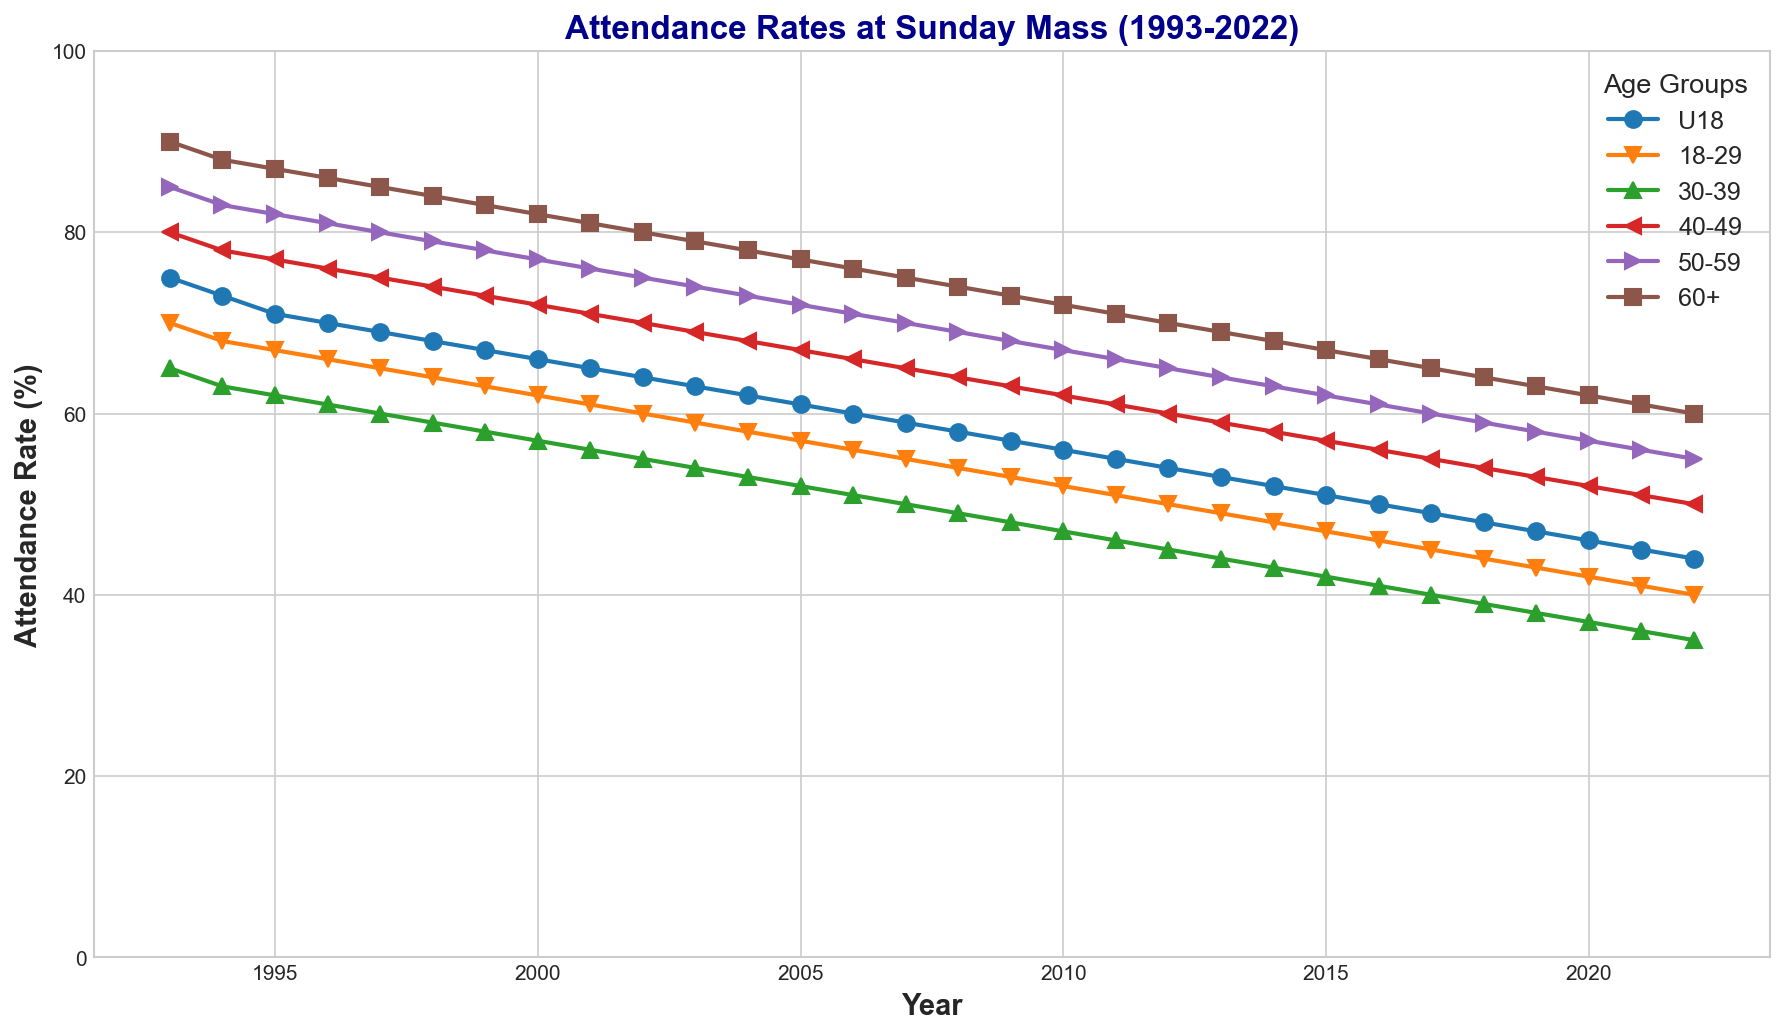what is the overall trend in attendance rates for the age group 18-29 from 1993 to 2022? To determine the overall trend, we look at the start (1993) and end values (2022) of the attendance rates for the 18-29 age group. In 1993, the rate was 70%, and in 2022, it was 40%. The trend is a decline in attendance over the period.
Answer: Declining which age group had the highest attendance rate in 1993 and 2022? In 1993, we observe the highest attendance rate by comparing the values for each age group. The 60+ age group had the highest rate at 90%. Repeating the process for 2022, the 60+ age group again had the highest attendance rate at 60%.
Answer: 60+ what is the difference in attendance rates between the age groups 30-39 and 50-59 in 2000? To find the difference, subtract the attendance rate of the 30-39 age group from that of the 50-59 age group for the year 2000. The rates are 57% and 77%, respectively. Thus, the difference is 77% - 57% = 20%.
Answer: 20% which age group experienced the largest decrease in attendance rates from 1993 to 2022? To find the largest decrease, we calculate the difference between 1993 and 2022 attendance rates for each age group and then identify the largest decrease. The differences are U18: 75%-44%=31%, 18-29: 70%-40%=30%, 30-39: 65%-35%=30%, 40-49: 80%-50%=30%, 50-59: 85%-55%=30%, 60+: 90%-60%=30%. The U18 age group experienced the largest decrease with a 31% drop.
Answer: U18 what is the average attendance rate for all age groups in the year 2010? To find the average attendance rate, sum the attendance rates of all age groups for 2010 and divide by the number of age groups. The rates are U18: 56%, 18-29: 52%, 30-39: 47%, 40-49: 62%, 50-59: 67%, 60+: 72%. The sum is 56+52+47+62+67+72 = 356, and the average is 356/6 = 59.33%.
Answer: 59.33% which age group shows a consistently higher attendance rate compared to the 18-29 age group across all the years? We compare the attendance rates of the 18-29 age group with each other age group across all years. The 60+ age group consistently has higher attendance rates in every year from 1993 to 2022.
Answer: 60+ what is the median attendance rate for the 50-59 age group from 1993 to 2022? To find the median, we list the attendance rates for the 50-59 age group from 1993 to 2022 and find the middle value. The rates are: 85, 83, 82, 81, 80, 79, 78, 77, 76, 75, 74, 73, 72, 71, 70, 69, 68, 67, 66, 65, 64, 63, 62, 61, 60, 59, 58, 57, 56, 55. With 30 data points, the median is the average of the 15th and 16th values: (70+69)/2 = 69.5%.
Answer: 69.5% what was the attendance rate for the age group U18 in the year 2005? We look at the attendance rate for the U18 age group in 2005. The plotted value is 61%.
Answer: 61% which year showed the most significant drop in attendance rate for the 40-49 age group, and what was the drop? We compare the year-to-year changes in attendance rates for the 40-49 age group and identify the year with the largest difference. The most significant drop occurred between 2002 and 2003, where the rate fell from 70% to 69%, a 1% drop.
Answer: 2002-2003, 1% 